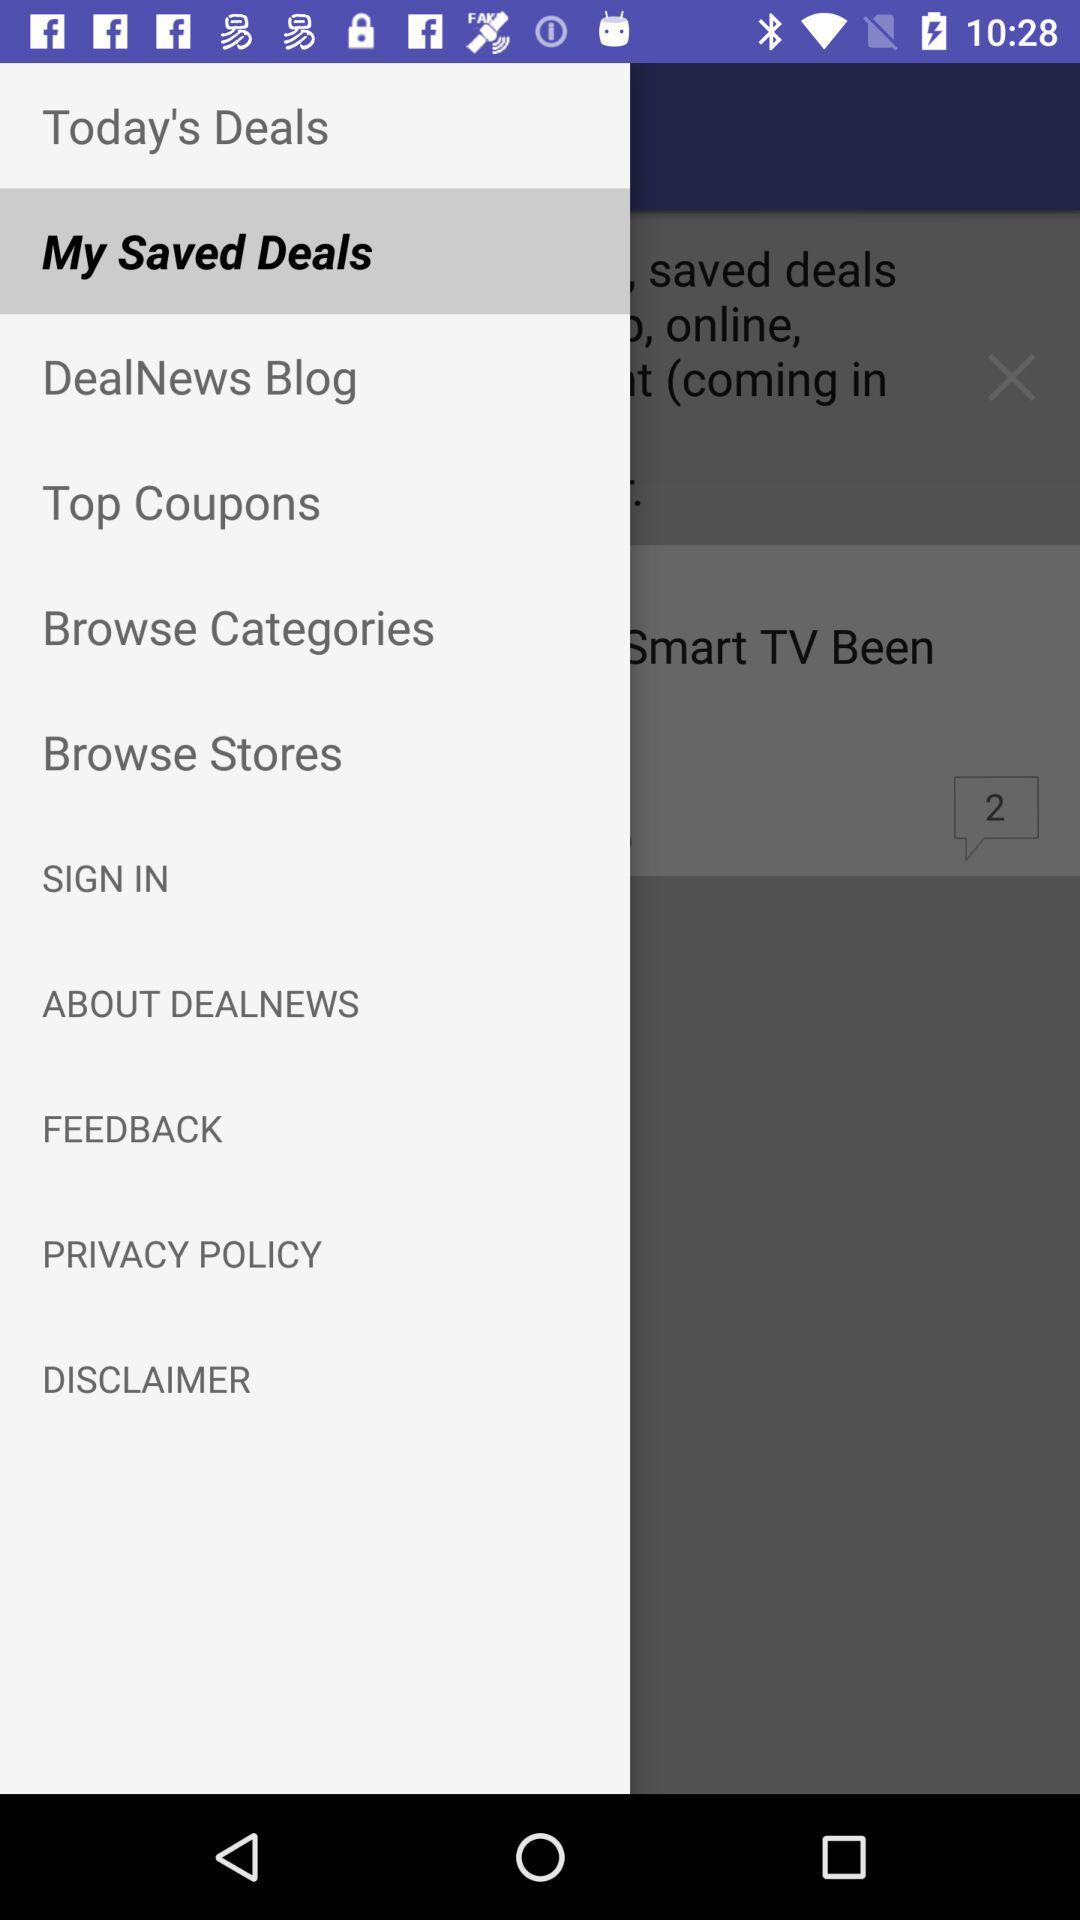What's the selected option? The selected option is "My Saved Deals". 